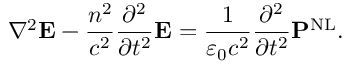Convert formula to latex. <formula><loc_0><loc_0><loc_500><loc_500>\nabla ^ { 2 } E - { \frac { n ^ { 2 } } { c ^ { 2 } } } { \frac { \partial ^ { 2 } } { \partial t ^ { 2 } } } E = { \frac { 1 } { \varepsilon _ { 0 } c ^ { 2 } } } { \frac { \partial ^ { 2 } } { \partial t ^ { 2 } } } P ^ { N L } .</formula> 